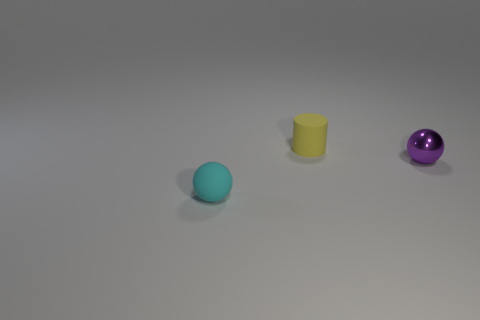Add 1 green things. How many objects exist? 4 Subtract all cylinders. How many objects are left? 2 Subtract all purple matte blocks. Subtract all tiny spheres. How many objects are left? 1 Add 3 yellow rubber cylinders. How many yellow rubber cylinders are left? 4 Add 1 purple metal objects. How many purple metal objects exist? 2 Subtract 0 cyan cylinders. How many objects are left? 3 